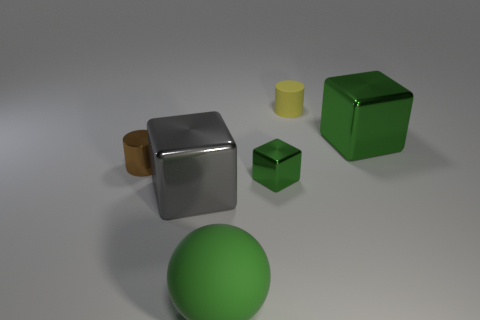Add 3 big green matte cylinders. How many objects exist? 9 Subtract all cylinders. How many objects are left? 4 Add 5 tiny rubber cylinders. How many tiny rubber cylinders are left? 6 Add 4 big gray spheres. How many big gray spheres exist? 4 Subtract 1 green cubes. How many objects are left? 5 Subtract all small brown shiny cylinders. Subtract all green cubes. How many objects are left? 3 